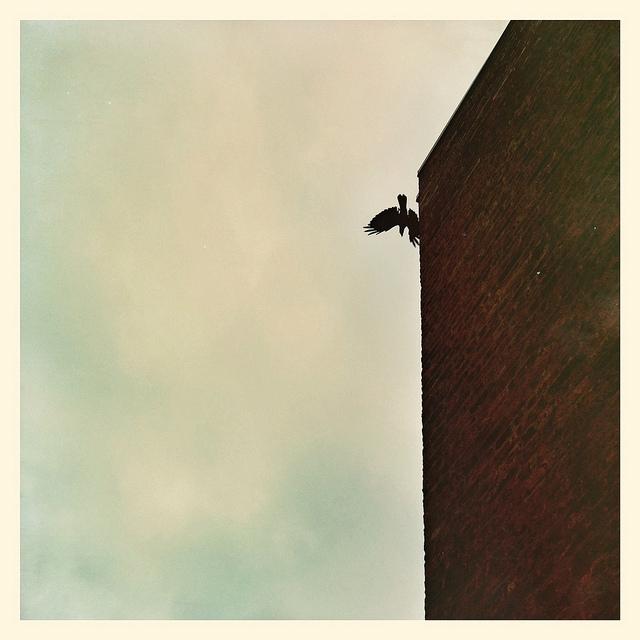What color is the bird?
Answer briefly. Black. What is the wall made of?
Quick response, please. Brick. Is there a clock tower on this building?
Quick response, please. No. What is the bird doing?
Write a very short answer. Flying. 